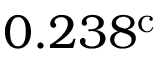Convert formula to latex. <formula><loc_0><loc_0><loc_500><loc_500>0 . 2 3 8 ^ { c }</formula> 